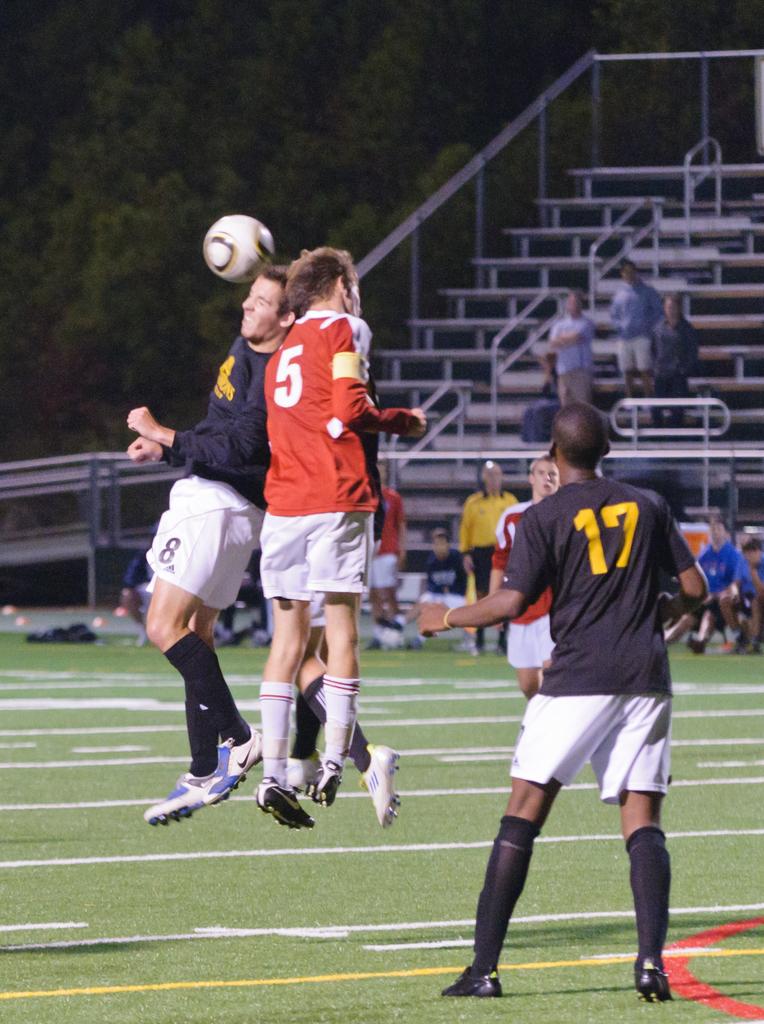What number is the player in black wearing?
Provide a succinct answer. 17. What is the number of the player in the red  shirt?
Ensure brevity in your answer.  5. 